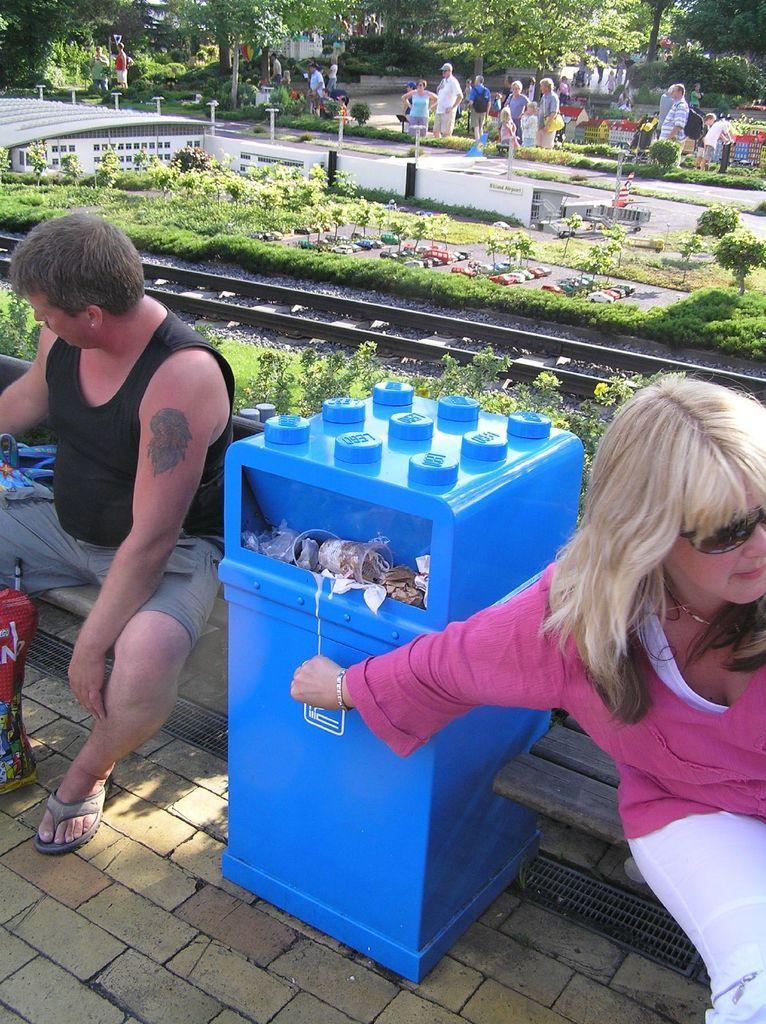Please provide a concise description of this image. There are two people sitting,in between these two people we can see trash in bin. In the background we can see grass,plants,people and trees. 